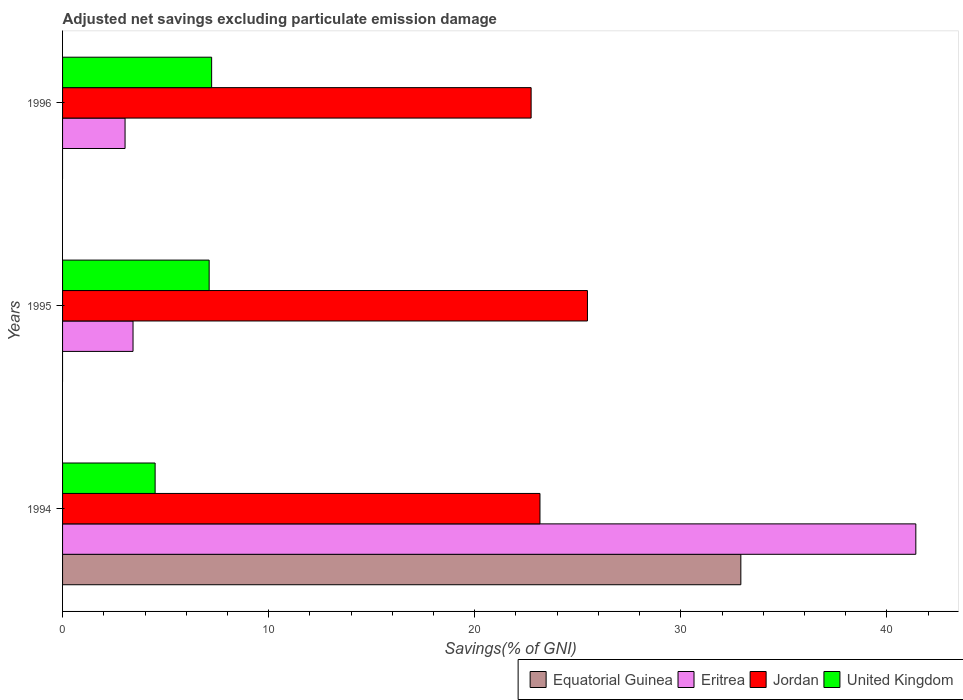What is the label of the 3rd group of bars from the top?
Ensure brevity in your answer.  1994. What is the adjusted net savings in Equatorial Guinea in 1995?
Offer a very short reply. 0. Across all years, what is the maximum adjusted net savings in United Kingdom?
Your response must be concise. 7.23. What is the total adjusted net savings in United Kingdom in the graph?
Offer a very short reply. 18.84. What is the difference between the adjusted net savings in Jordan in 1995 and that in 1996?
Offer a terse response. 2.73. What is the difference between the adjusted net savings in Equatorial Guinea in 1994 and the adjusted net savings in Eritrea in 1995?
Your response must be concise. 29.49. What is the average adjusted net savings in Jordan per year?
Offer a terse response. 23.79. In the year 1994, what is the difference between the adjusted net savings in United Kingdom and adjusted net savings in Eritrea?
Keep it short and to the point. -36.91. What is the ratio of the adjusted net savings in Jordan in 1995 to that in 1996?
Keep it short and to the point. 1.12. What is the difference between the highest and the second highest adjusted net savings in Eritrea?
Offer a terse response. 37.98. What is the difference between the highest and the lowest adjusted net savings in Eritrea?
Your answer should be compact. 38.37. In how many years, is the adjusted net savings in Eritrea greater than the average adjusted net savings in Eritrea taken over all years?
Offer a terse response. 1. Is it the case that in every year, the sum of the adjusted net savings in Equatorial Guinea and adjusted net savings in United Kingdom is greater than the adjusted net savings in Eritrea?
Give a very brief answer. No. How many years are there in the graph?
Provide a short and direct response. 3. Are the values on the major ticks of X-axis written in scientific E-notation?
Ensure brevity in your answer.  No. Does the graph contain any zero values?
Your answer should be very brief. Yes. Does the graph contain grids?
Offer a terse response. No. Where does the legend appear in the graph?
Your response must be concise. Bottom right. How are the legend labels stacked?
Make the answer very short. Horizontal. What is the title of the graph?
Make the answer very short. Adjusted net savings excluding particulate emission damage. What is the label or title of the X-axis?
Provide a short and direct response. Savings(% of GNI). What is the Savings(% of GNI) of Equatorial Guinea in 1994?
Your answer should be compact. 32.91. What is the Savings(% of GNI) of Eritrea in 1994?
Your answer should be compact. 41.4. What is the Savings(% of GNI) in Jordan in 1994?
Offer a terse response. 23.16. What is the Savings(% of GNI) in United Kingdom in 1994?
Give a very brief answer. 4.49. What is the Savings(% of GNI) in Equatorial Guinea in 1995?
Make the answer very short. 0. What is the Savings(% of GNI) in Eritrea in 1995?
Provide a short and direct response. 3.42. What is the Savings(% of GNI) of Jordan in 1995?
Offer a very short reply. 25.47. What is the Savings(% of GNI) in United Kingdom in 1995?
Keep it short and to the point. 7.11. What is the Savings(% of GNI) in Equatorial Guinea in 1996?
Keep it short and to the point. 0. What is the Savings(% of GNI) in Eritrea in 1996?
Keep it short and to the point. 3.03. What is the Savings(% of GNI) of Jordan in 1996?
Offer a terse response. 22.74. What is the Savings(% of GNI) of United Kingdom in 1996?
Ensure brevity in your answer.  7.23. Across all years, what is the maximum Savings(% of GNI) of Equatorial Guinea?
Give a very brief answer. 32.91. Across all years, what is the maximum Savings(% of GNI) of Eritrea?
Provide a succinct answer. 41.4. Across all years, what is the maximum Savings(% of GNI) in Jordan?
Keep it short and to the point. 25.47. Across all years, what is the maximum Savings(% of GNI) in United Kingdom?
Your answer should be very brief. 7.23. Across all years, what is the minimum Savings(% of GNI) in Eritrea?
Your answer should be very brief. 3.03. Across all years, what is the minimum Savings(% of GNI) in Jordan?
Your answer should be very brief. 22.74. Across all years, what is the minimum Savings(% of GNI) of United Kingdom?
Make the answer very short. 4.49. What is the total Savings(% of GNI) of Equatorial Guinea in the graph?
Give a very brief answer. 32.91. What is the total Savings(% of GNI) in Eritrea in the graph?
Keep it short and to the point. 47.85. What is the total Savings(% of GNI) of Jordan in the graph?
Make the answer very short. 71.37. What is the total Savings(% of GNI) in United Kingdom in the graph?
Your answer should be compact. 18.84. What is the difference between the Savings(% of GNI) of Eritrea in 1994 and that in 1995?
Ensure brevity in your answer.  37.98. What is the difference between the Savings(% of GNI) in Jordan in 1994 and that in 1995?
Provide a succinct answer. -2.3. What is the difference between the Savings(% of GNI) of United Kingdom in 1994 and that in 1995?
Your answer should be very brief. -2.62. What is the difference between the Savings(% of GNI) of Eritrea in 1994 and that in 1996?
Provide a succinct answer. 38.37. What is the difference between the Savings(% of GNI) of Jordan in 1994 and that in 1996?
Your answer should be compact. 0.43. What is the difference between the Savings(% of GNI) in United Kingdom in 1994 and that in 1996?
Your response must be concise. -2.74. What is the difference between the Savings(% of GNI) in Eritrea in 1995 and that in 1996?
Provide a short and direct response. 0.39. What is the difference between the Savings(% of GNI) in Jordan in 1995 and that in 1996?
Your answer should be very brief. 2.73. What is the difference between the Savings(% of GNI) of United Kingdom in 1995 and that in 1996?
Give a very brief answer. -0.12. What is the difference between the Savings(% of GNI) of Equatorial Guinea in 1994 and the Savings(% of GNI) of Eritrea in 1995?
Your answer should be very brief. 29.49. What is the difference between the Savings(% of GNI) in Equatorial Guinea in 1994 and the Savings(% of GNI) in Jordan in 1995?
Offer a very short reply. 7.44. What is the difference between the Savings(% of GNI) in Equatorial Guinea in 1994 and the Savings(% of GNI) in United Kingdom in 1995?
Keep it short and to the point. 25.8. What is the difference between the Savings(% of GNI) in Eritrea in 1994 and the Savings(% of GNI) in Jordan in 1995?
Keep it short and to the point. 15.93. What is the difference between the Savings(% of GNI) in Eritrea in 1994 and the Savings(% of GNI) in United Kingdom in 1995?
Your answer should be compact. 34.29. What is the difference between the Savings(% of GNI) of Jordan in 1994 and the Savings(% of GNI) of United Kingdom in 1995?
Provide a succinct answer. 16.05. What is the difference between the Savings(% of GNI) of Equatorial Guinea in 1994 and the Savings(% of GNI) of Eritrea in 1996?
Provide a succinct answer. 29.88. What is the difference between the Savings(% of GNI) in Equatorial Guinea in 1994 and the Savings(% of GNI) in Jordan in 1996?
Keep it short and to the point. 10.18. What is the difference between the Savings(% of GNI) in Equatorial Guinea in 1994 and the Savings(% of GNI) in United Kingdom in 1996?
Ensure brevity in your answer.  25.68. What is the difference between the Savings(% of GNI) in Eritrea in 1994 and the Savings(% of GNI) in Jordan in 1996?
Your answer should be compact. 18.67. What is the difference between the Savings(% of GNI) in Eritrea in 1994 and the Savings(% of GNI) in United Kingdom in 1996?
Provide a short and direct response. 34.17. What is the difference between the Savings(% of GNI) of Jordan in 1994 and the Savings(% of GNI) of United Kingdom in 1996?
Offer a terse response. 15.93. What is the difference between the Savings(% of GNI) of Eritrea in 1995 and the Savings(% of GNI) of Jordan in 1996?
Your answer should be very brief. -19.32. What is the difference between the Savings(% of GNI) in Eritrea in 1995 and the Savings(% of GNI) in United Kingdom in 1996?
Your response must be concise. -3.81. What is the difference between the Savings(% of GNI) of Jordan in 1995 and the Savings(% of GNI) of United Kingdom in 1996?
Offer a very short reply. 18.23. What is the average Savings(% of GNI) in Equatorial Guinea per year?
Provide a short and direct response. 10.97. What is the average Savings(% of GNI) of Eritrea per year?
Make the answer very short. 15.95. What is the average Savings(% of GNI) of Jordan per year?
Give a very brief answer. 23.79. What is the average Savings(% of GNI) in United Kingdom per year?
Your answer should be very brief. 6.28. In the year 1994, what is the difference between the Savings(% of GNI) in Equatorial Guinea and Savings(% of GNI) in Eritrea?
Offer a terse response. -8.49. In the year 1994, what is the difference between the Savings(% of GNI) of Equatorial Guinea and Savings(% of GNI) of Jordan?
Provide a short and direct response. 9.75. In the year 1994, what is the difference between the Savings(% of GNI) in Equatorial Guinea and Savings(% of GNI) in United Kingdom?
Provide a succinct answer. 28.42. In the year 1994, what is the difference between the Savings(% of GNI) of Eritrea and Savings(% of GNI) of Jordan?
Give a very brief answer. 18.24. In the year 1994, what is the difference between the Savings(% of GNI) in Eritrea and Savings(% of GNI) in United Kingdom?
Provide a succinct answer. 36.91. In the year 1994, what is the difference between the Savings(% of GNI) in Jordan and Savings(% of GNI) in United Kingdom?
Make the answer very short. 18.67. In the year 1995, what is the difference between the Savings(% of GNI) of Eritrea and Savings(% of GNI) of Jordan?
Offer a very short reply. -22.05. In the year 1995, what is the difference between the Savings(% of GNI) of Eritrea and Savings(% of GNI) of United Kingdom?
Your answer should be compact. -3.69. In the year 1995, what is the difference between the Savings(% of GNI) of Jordan and Savings(% of GNI) of United Kingdom?
Your answer should be very brief. 18.36. In the year 1996, what is the difference between the Savings(% of GNI) in Eritrea and Savings(% of GNI) in Jordan?
Your answer should be very brief. -19.7. In the year 1996, what is the difference between the Savings(% of GNI) of Eritrea and Savings(% of GNI) of United Kingdom?
Provide a succinct answer. -4.2. In the year 1996, what is the difference between the Savings(% of GNI) in Jordan and Savings(% of GNI) in United Kingdom?
Provide a succinct answer. 15.5. What is the ratio of the Savings(% of GNI) in Eritrea in 1994 to that in 1995?
Your answer should be very brief. 12.11. What is the ratio of the Savings(% of GNI) in Jordan in 1994 to that in 1995?
Keep it short and to the point. 0.91. What is the ratio of the Savings(% of GNI) in United Kingdom in 1994 to that in 1995?
Your response must be concise. 0.63. What is the ratio of the Savings(% of GNI) of Eritrea in 1994 to that in 1996?
Provide a succinct answer. 13.65. What is the ratio of the Savings(% of GNI) of Jordan in 1994 to that in 1996?
Provide a short and direct response. 1.02. What is the ratio of the Savings(% of GNI) in United Kingdom in 1994 to that in 1996?
Provide a short and direct response. 0.62. What is the ratio of the Savings(% of GNI) of Eritrea in 1995 to that in 1996?
Ensure brevity in your answer.  1.13. What is the ratio of the Savings(% of GNI) of Jordan in 1995 to that in 1996?
Your answer should be very brief. 1.12. What is the ratio of the Savings(% of GNI) of United Kingdom in 1995 to that in 1996?
Keep it short and to the point. 0.98. What is the difference between the highest and the second highest Savings(% of GNI) of Eritrea?
Ensure brevity in your answer.  37.98. What is the difference between the highest and the second highest Savings(% of GNI) in Jordan?
Provide a short and direct response. 2.3. What is the difference between the highest and the second highest Savings(% of GNI) of United Kingdom?
Provide a succinct answer. 0.12. What is the difference between the highest and the lowest Savings(% of GNI) of Equatorial Guinea?
Make the answer very short. 32.91. What is the difference between the highest and the lowest Savings(% of GNI) of Eritrea?
Your response must be concise. 38.37. What is the difference between the highest and the lowest Savings(% of GNI) in Jordan?
Your answer should be compact. 2.73. What is the difference between the highest and the lowest Savings(% of GNI) in United Kingdom?
Offer a very short reply. 2.74. 